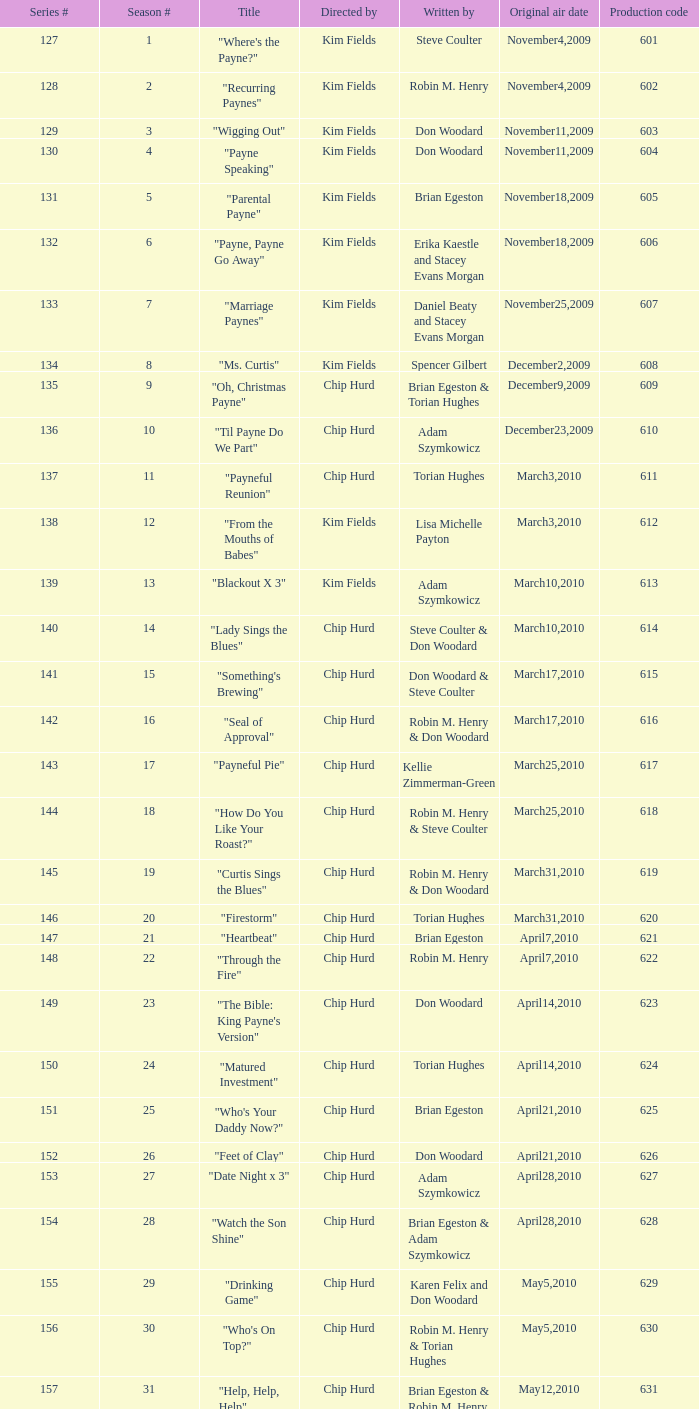What is the original air dates for the title "firestorm"? March31,2010. 